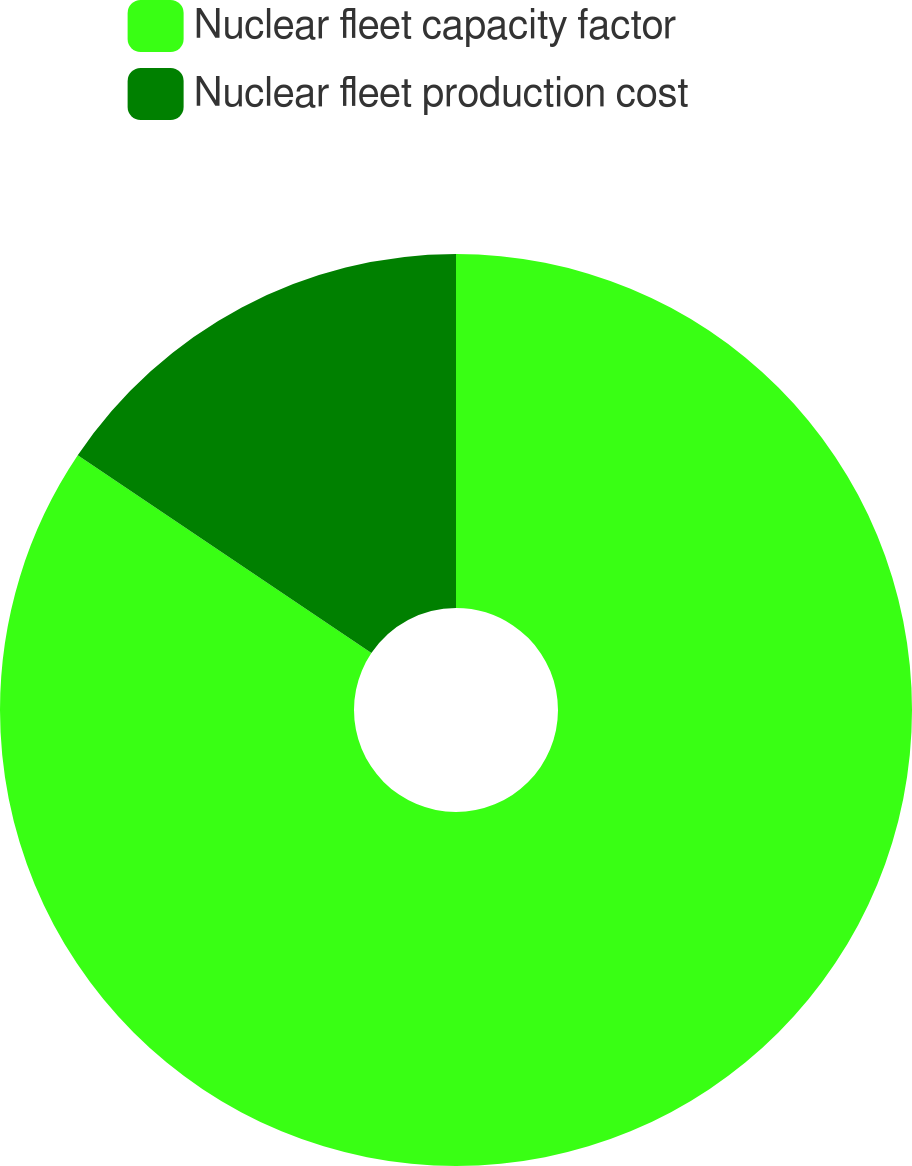Convert chart to OTSL. <chart><loc_0><loc_0><loc_500><loc_500><pie_chart><fcel>Nuclear fleet capacity factor<fcel>Nuclear fleet production cost<nl><fcel>84.43%<fcel>15.57%<nl></chart> 